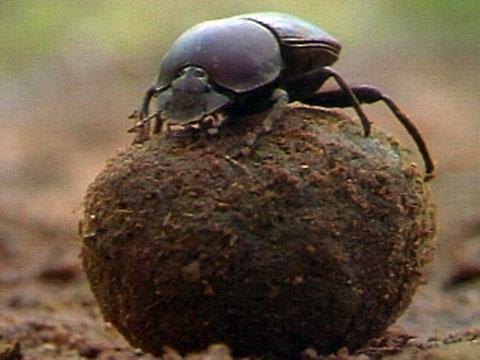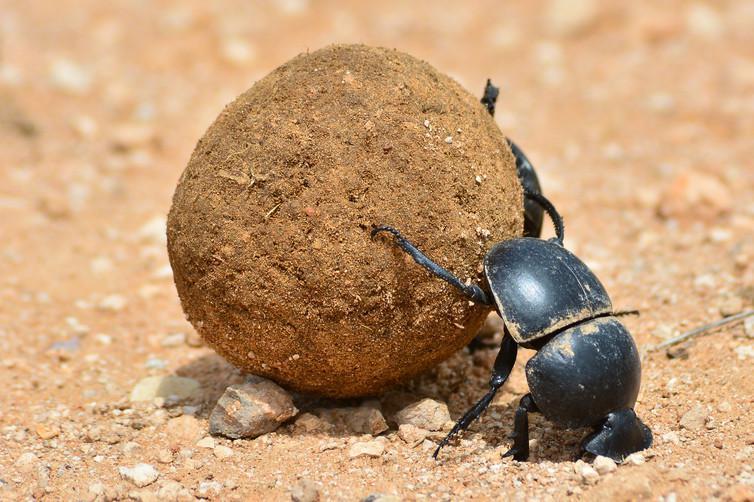The first image is the image on the left, the second image is the image on the right. Analyze the images presented: Is the assertion "At least one of the beetles is not on a clod of dirt." valid? Answer yes or no. No. The first image is the image on the left, the second image is the image on the right. Analyze the images presented: Is the assertion "At least one beetle crawls on a clod of dirt in each of the images." valid? Answer yes or no. Yes. The first image is the image on the left, the second image is the image on the right. Evaluate the accuracy of this statement regarding the images: "Both images show a beetle in contact with a round dung ball.". Is it true? Answer yes or no. Yes. The first image is the image on the left, the second image is the image on the right. For the images shown, is this caption "there are two insects in the image on the left." true? Answer yes or no. No. The first image is the image on the left, the second image is the image on the right. Given the left and right images, does the statement "There are at least two beetles touching  a dungball." hold true? Answer yes or no. Yes. The first image is the image on the left, the second image is the image on the right. For the images shown, is this caption "The photos contain a total of three beetles." true? Answer yes or no. No. The first image is the image on the left, the second image is the image on the right. Given the left and right images, does the statement "Two beetles are shown with a ball of dirt in one of the images." hold true? Answer yes or no. No. The first image is the image on the left, the second image is the image on the right. Examine the images to the left and right. Is the description "The beetle in the image on the left is sitting on top the clod of dirt." accurate? Answer yes or no. Yes. The first image is the image on the left, the second image is the image on the right. Evaluate the accuracy of this statement regarding the images: "One image features two beetles on opposite sides of a dung ball.". Is it true? Answer yes or no. No. The first image is the image on the left, the second image is the image on the right. Examine the images to the left and right. Is the description "An image shows a beetle atop a dung ball, so its body is parallel with the ground." accurate? Answer yes or no. Yes. 